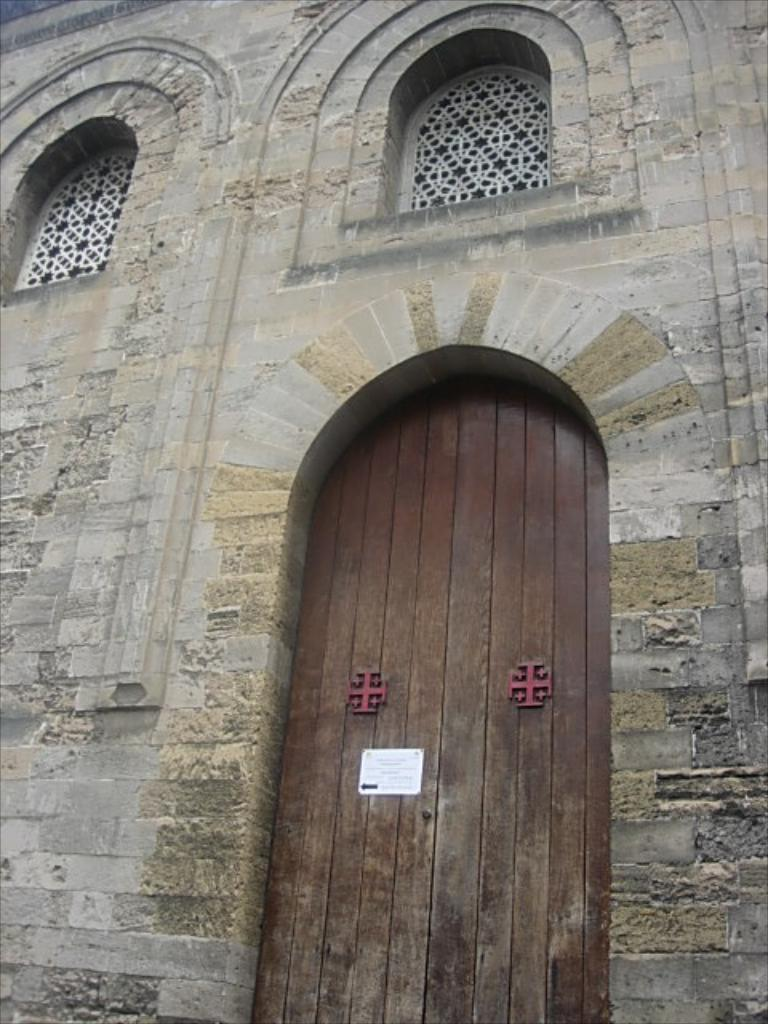What is the main structure visible in the image? There is a building wall in the image. What feature can be seen on the wall? There is a long wooden door on the wall. Is there anything attached to the door? Yes, there is a small white color slip attached to the door. Can you see any roses growing near the door in the image? There are no roses visible in the image; it only features a building wall, a long wooden door, and a small white color slip. 